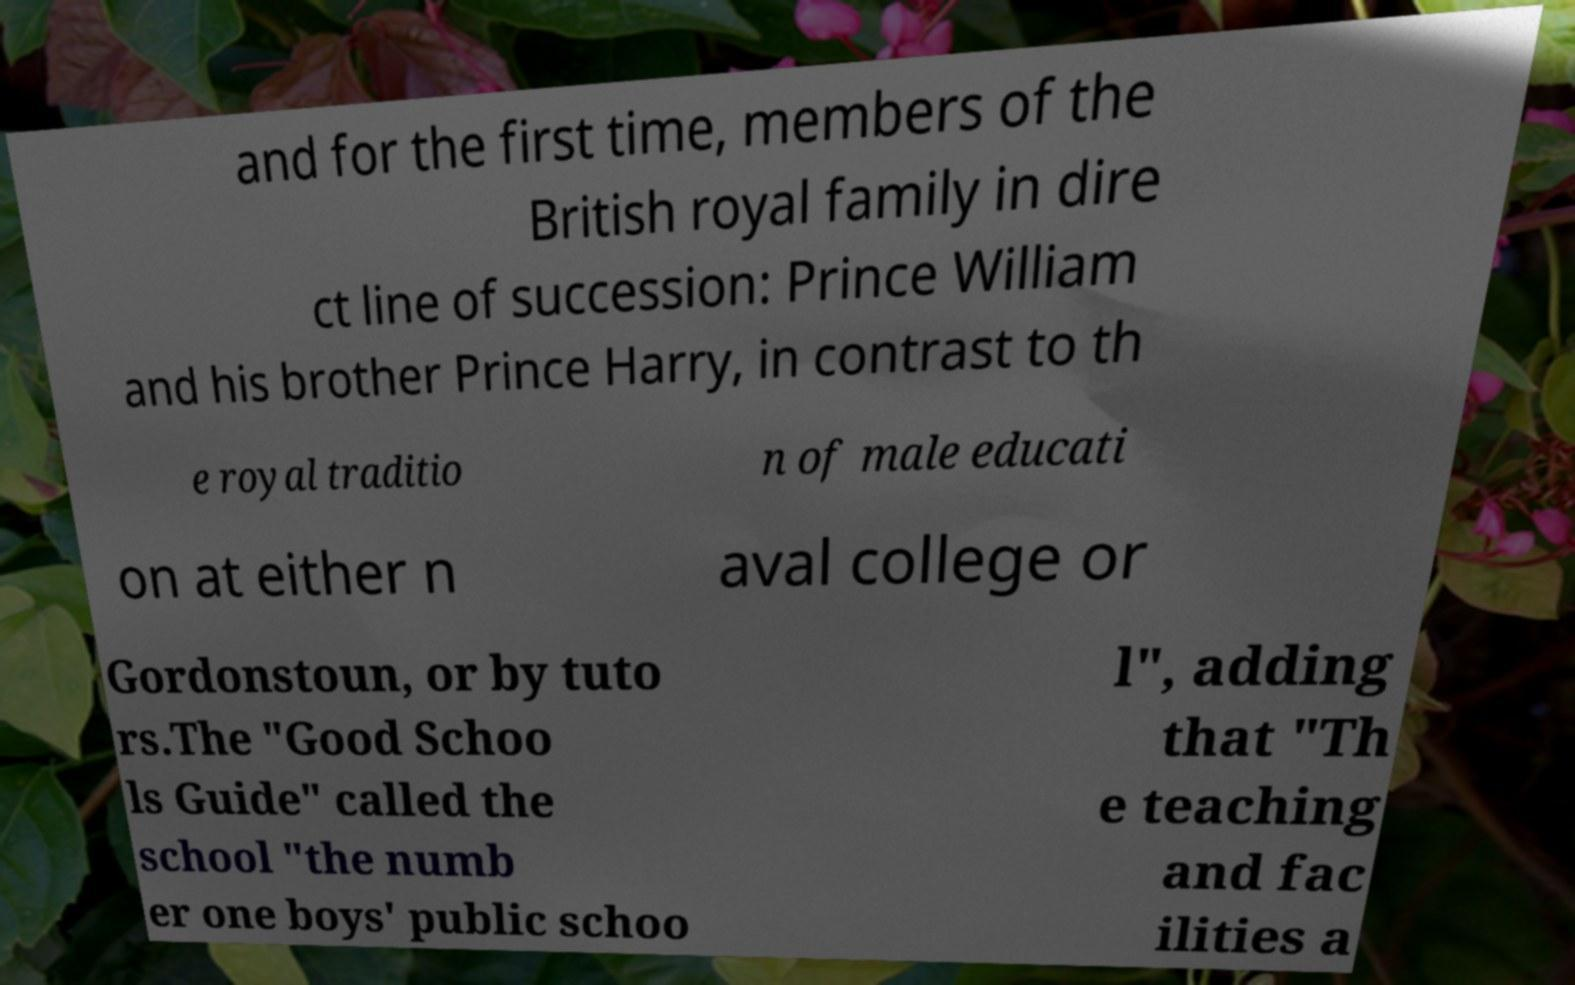Could you assist in decoding the text presented in this image and type it out clearly? and for the first time, members of the British royal family in dire ct line of succession: Prince William and his brother Prince Harry, in contrast to th e royal traditio n of male educati on at either n aval college or Gordonstoun, or by tuto rs.The "Good Schoo ls Guide" called the school "the numb er one boys' public schoo l", adding that "Th e teaching and fac ilities a 